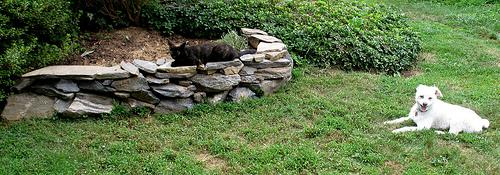Question: what is laying in the yard?
Choices:
A. Dog.
B. Pool.
C. Bikes.
D. Ants.
Answer with the letter. Answer: A Question: where is the cat laying?
Choices:
A. Pillow.
B. Rocks.
C. Bed.
D. Sofa.
Answer with the letter. Answer: B Question: what color is the grass?
Choices:
A. Brown.
B. Grey.
C. Green.
D. Black.
Answer with the letter. Answer: C Question: how many animals are shown?
Choices:
A. One.
B. Three.
C. Two.
D. Four.
Answer with the letter. Answer: C Question: what are the animals doing?
Choices:
A. Laying.
B. Eating.
C. Sleeping.
D. Playing.
Answer with the letter. Answer: A 